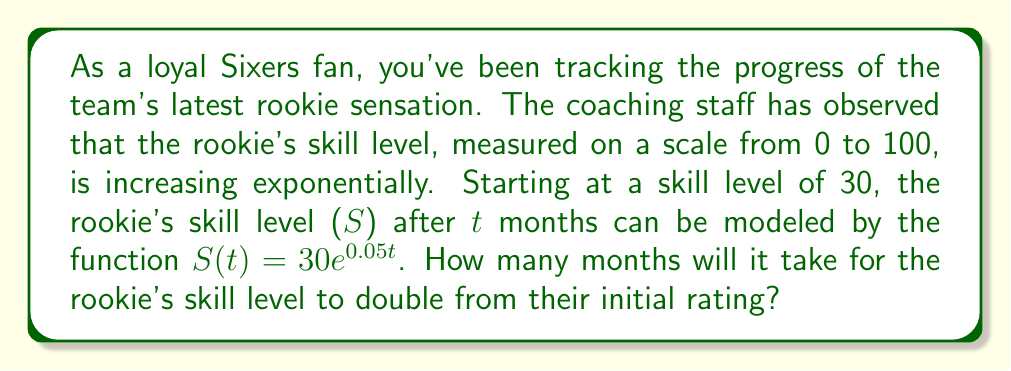Solve this math problem. Let's approach this step-by-step:

1) We want to find t when S(t) is double the initial skill level.
   Initial skill level = 30
   Double the initial skill level = 60

2) We can set up the equation:
   $60 = 30e^{0.05t}$

3) Divide both sides by 30:
   $2 = e^{0.05t}$

4) Take the natural log of both sides:
   $\ln(2) = \ln(e^{0.05t})$

5) Simplify the right side using the property of logarithms:
   $\ln(2) = 0.05t$

6) Solve for t:
   $t = \frac{\ln(2)}{0.05}$

7) Calculate the result:
   $t = \frac{0.693147...}{0.05} \approx 13.86$

Therefore, it will take approximately 13.86 months for the rookie's skill level to double.
Answer: $t \approx 13.86$ months 